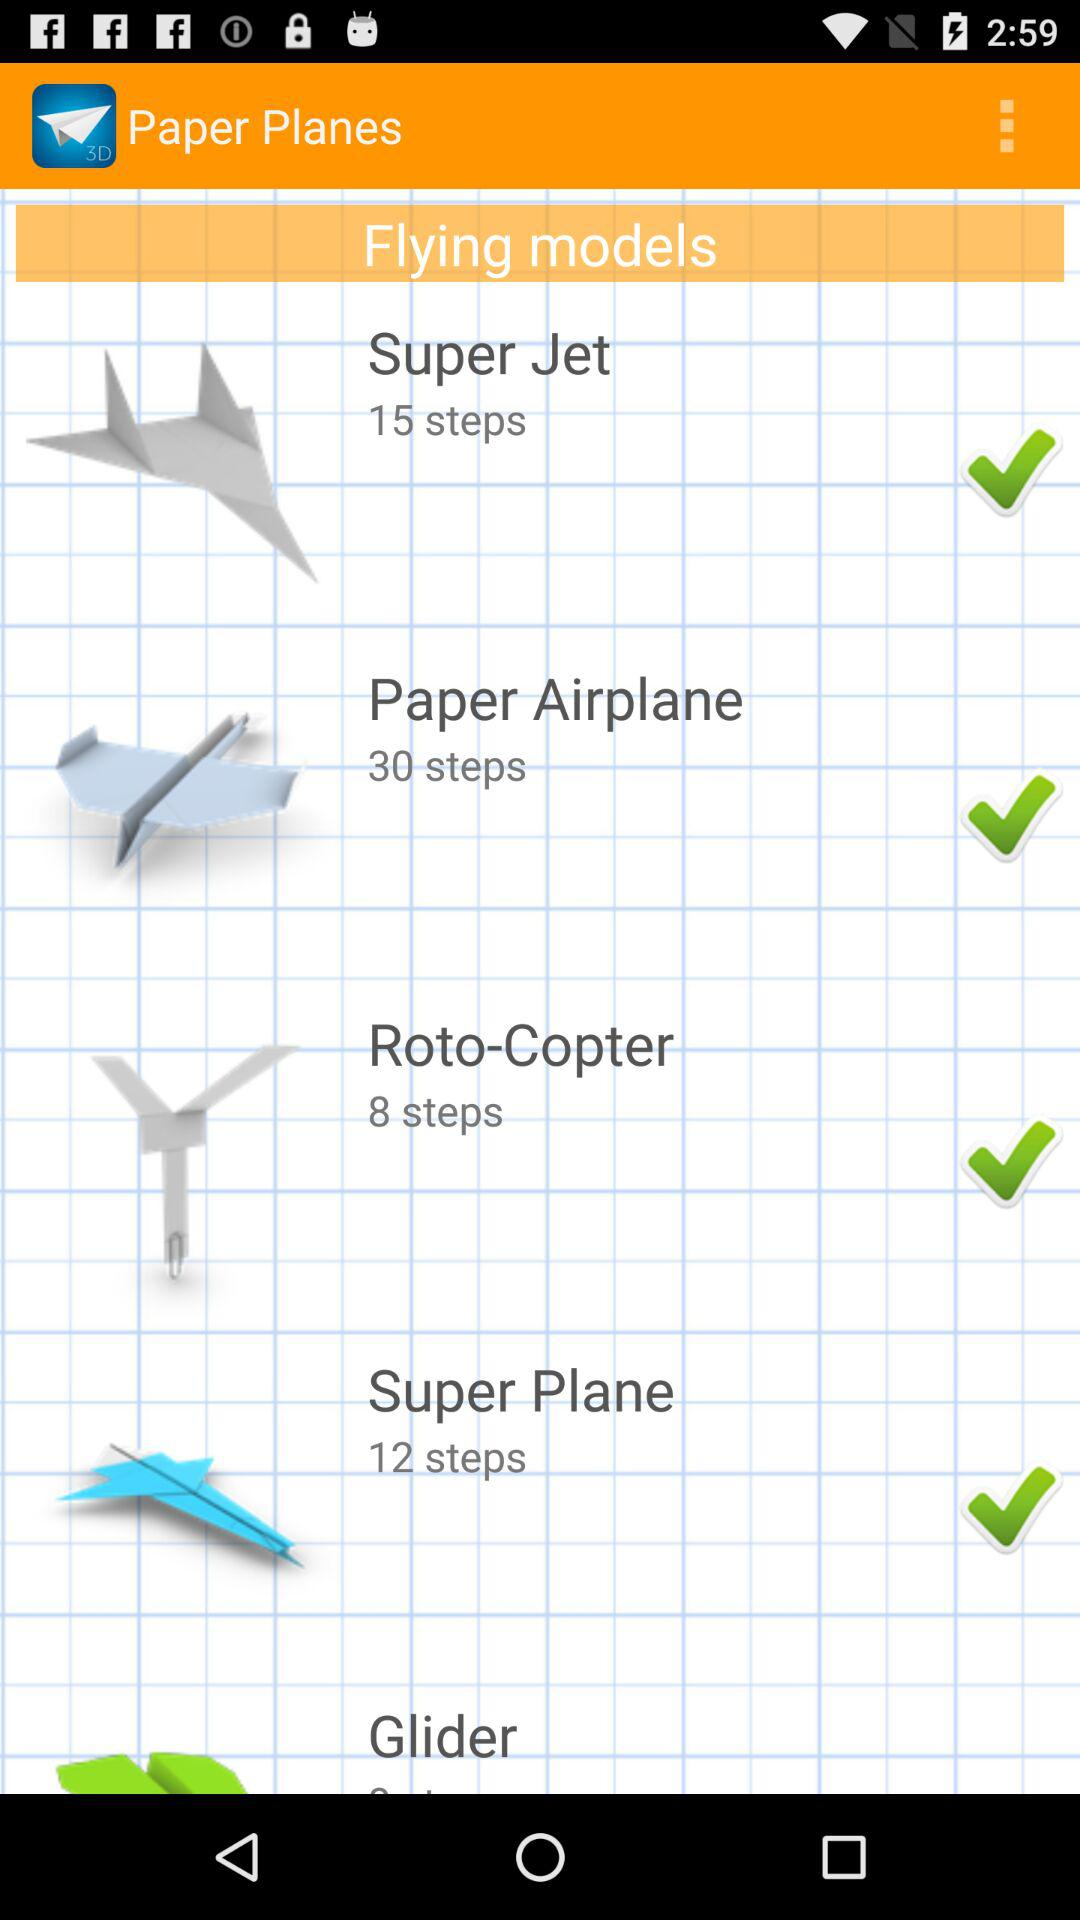What is the number of steps to create the "Roto-Copter"? The number of steps to create the "Roto-Copter" is 8. 